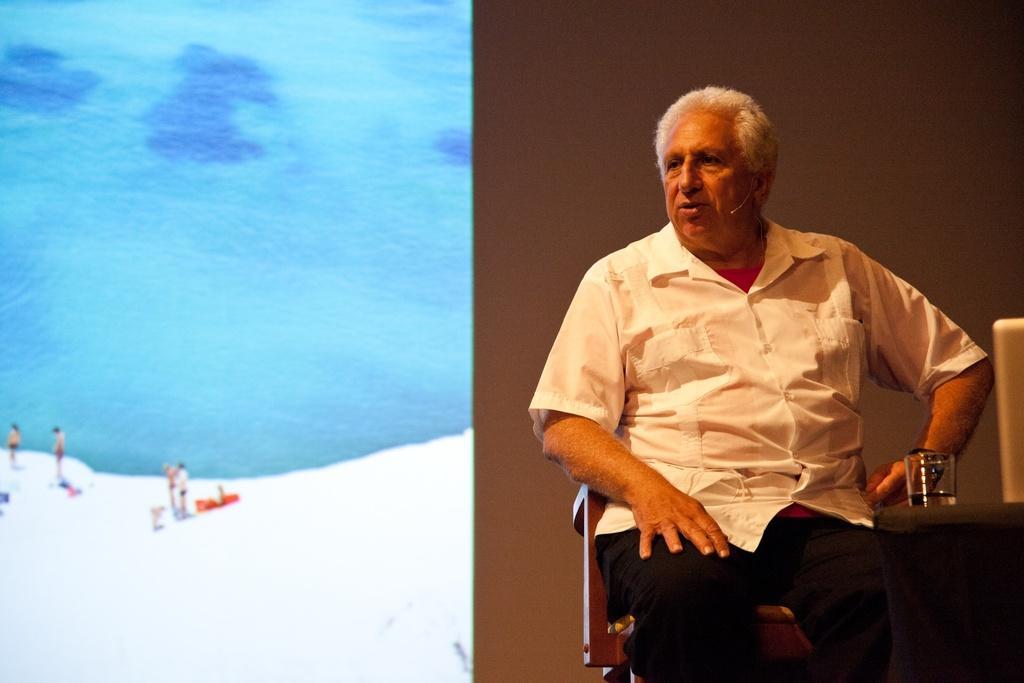Can you describe this image briefly? In this image I can see a man is sitting. The man is wearing white color shirt and pant. Here I can see a glass and other object an object. On the left side I can see water and people. 